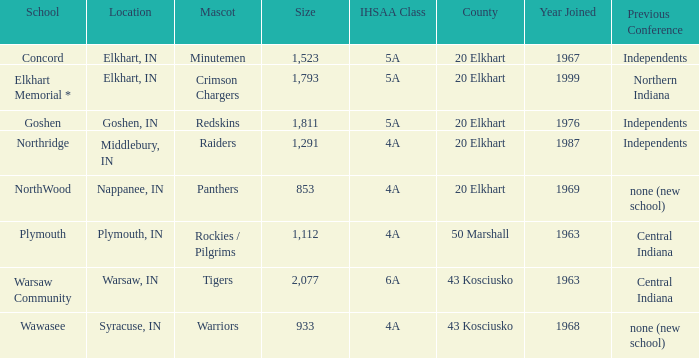Which country enrolled before 1976, featuring an ihssa classification of 5a, and a dimension bigger than 1,112? 20 Elkhart. 